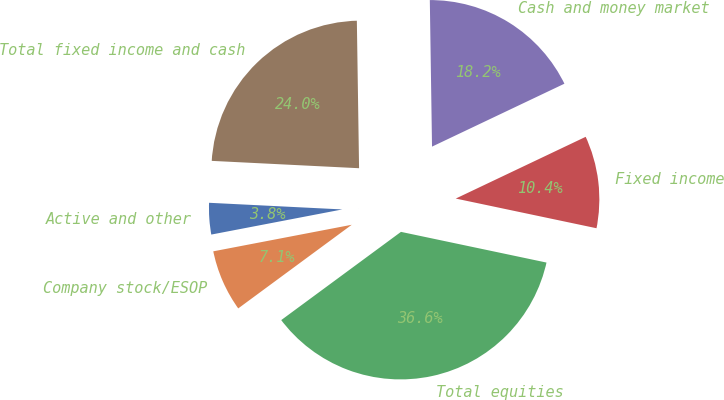<chart> <loc_0><loc_0><loc_500><loc_500><pie_chart><fcel>Active and other<fcel>Company stock/ESOP<fcel>Total equities<fcel>Fixed income<fcel>Cash and money market<fcel>Total fixed income and cash<nl><fcel>3.81%<fcel>7.09%<fcel>36.59%<fcel>10.37%<fcel>18.18%<fcel>23.97%<nl></chart> 